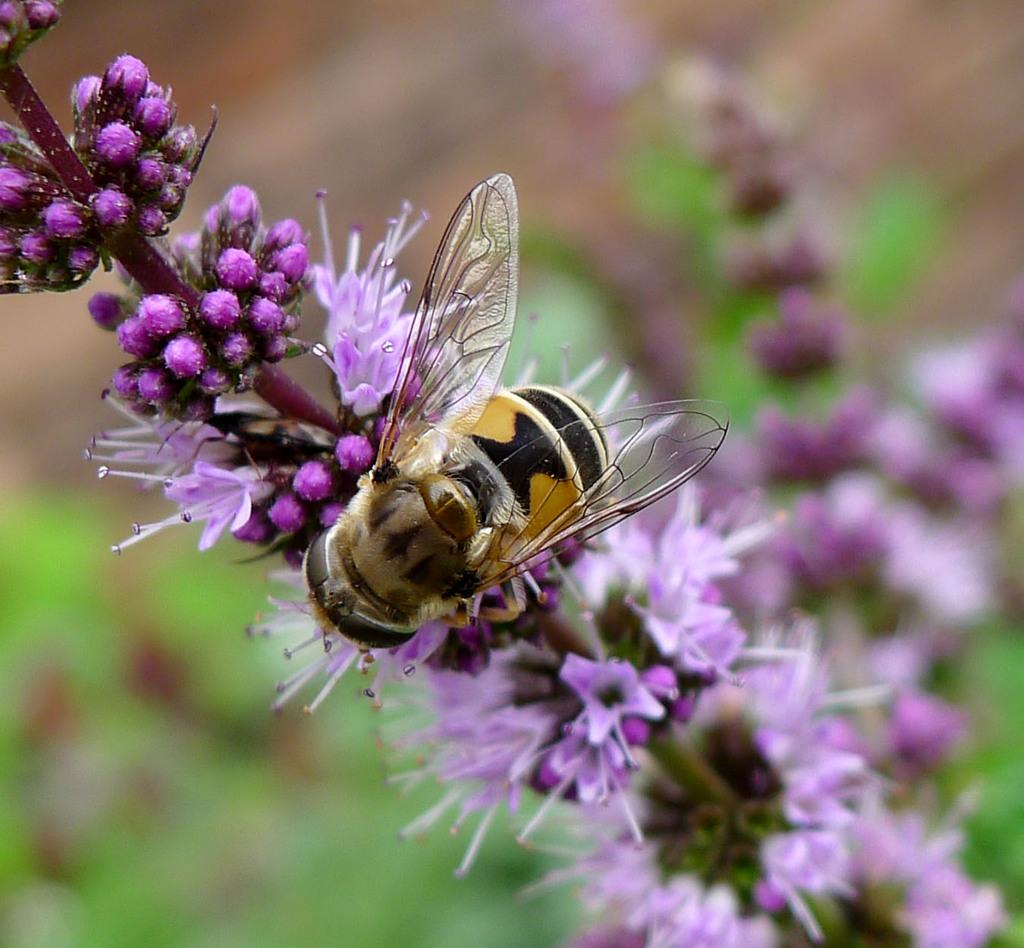What type of insect can be seen in the picture? There is a honey bee in the picture. Where is the honey bee located in the picture? The honey bee is on the branch of a flowering plant. How many babies are visible in the picture? There are no babies present in the picture; it features a honey bee on a flowering plant. What type of pot is being used to lift the honey bee in the picture? There is no pot or lifting action present in the picture; the honey bee is on the branch of a flowering plant. 